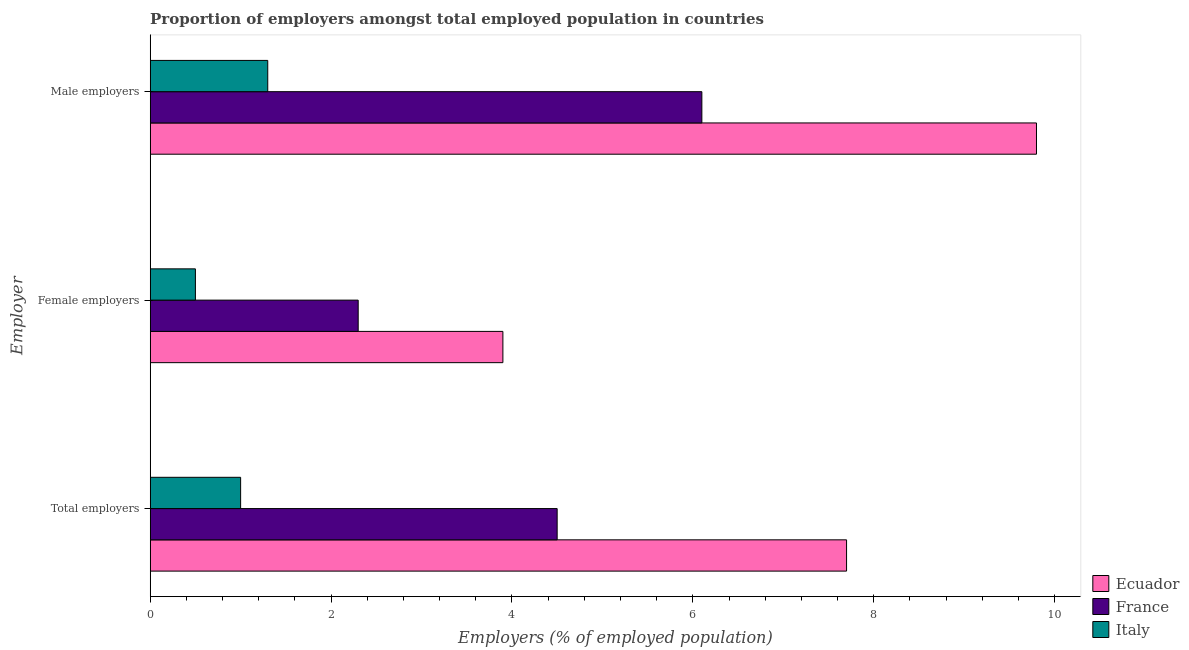Are the number of bars on each tick of the Y-axis equal?
Keep it short and to the point. Yes. How many bars are there on the 3rd tick from the top?
Your answer should be very brief. 3. What is the label of the 1st group of bars from the top?
Offer a very short reply. Male employers. What is the percentage of total employers in Ecuador?
Your response must be concise. 7.7. Across all countries, what is the maximum percentage of total employers?
Your answer should be compact. 7.7. In which country was the percentage of total employers maximum?
Keep it short and to the point. Ecuador. In which country was the percentage of female employers minimum?
Make the answer very short. Italy. What is the total percentage of total employers in the graph?
Your answer should be compact. 13.2. What is the difference between the percentage of total employers in Ecuador and that in France?
Provide a succinct answer. 3.2. What is the difference between the percentage of male employers in Italy and the percentage of total employers in France?
Your answer should be very brief. -3.2. What is the average percentage of total employers per country?
Your answer should be very brief. 4.4. What is the difference between the percentage of male employers and percentage of female employers in Ecuador?
Provide a short and direct response. 5.9. In how many countries, is the percentage of male employers greater than 3.2 %?
Offer a terse response. 2. What is the ratio of the percentage of male employers in Ecuador to that in Italy?
Ensure brevity in your answer.  7.54. Is the percentage of female employers in France less than that in Italy?
Keep it short and to the point. No. Is the difference between the percentage of total employers in France and Italy greater than the difference between the percentage of male employers in France and Italy?
Provide a short and direct response. No. What is the difference between the highest and the second highest percentage of male employers?
Provide a short and direct response. 3.7. What is the difference between the highest and the lowest percentage of total employers?
Provide a short and direct response. 6.7. In how many countries, is the percentage of female employers greater than the average percentage of female employers taken over all countries?
Your answer should be very brief. 2. Is the sum of the percentage of female employers in France and Ecuador greater than the maximum percentage of male employers across all countries?
Ensure brevity in your answer.  No. What does the 2nd bar from the top in Total employers represents?
Your response must be concise. France. Are all the bars in the graph horizontal?
Keep it short and to the point. Yes. Are the values on the major ticks of X-axis written in scientific E-notation?
Provide a short and direct response. No. Does the graph contain any zero values?
Your answer should be compact. No. Does the graph contain grids?
Make the answer very short. No. Where does the legend appear in the graph?
Give a very brief answer. Bottom right. How are the legend labels stacked?
Make the answer very short. Vertical. What is the title of the graph?
Offer a terse response. Proportion of employers amongst total employed population in countries. Does "World" appear as one of the legend labels in the graph?
Give a very brief answer. No. What is the label or title of the X-axis?
Give a very brief answer. Employers (% of employed population). What is the label or title of the Y-axis?
Offer a very short reply. Employer. What is the Employers (% of employed population) in Ecuador in Total employers?
Keep it short and to the point. 7.7. What is the Employers (% of employed population) of France in Total employers?
Offer a terse response. 4.5. What is the Employers (% of employed population) in Ecuador in Female employers?
Ensure brevity in your answer.  3.9. What is the Employers (% of employed population) in France in Female employers?
Provide a short and direct response. 2.3. What is the Employers (% of employed population) of Italy in Female employers?
Provide a succinct answer. 0.5. What is the Employers (% of employed population) of Ecuador in Male employers?
Give a very brief answer. 9.8. What is the Employers (% of employed population) in France in Male employers?
Your response must be concise. 6.1. What is the Employers (% of employed population) of Italy in Male employers?
Provide a short and direct response. 1.3. Across all Employer, what is the maximum Employers (% of employed population) of Ecuador?
Provide a succinct answer. 9.8. Across all Employer, what is the maximum Employers (% of employed population) of France?
Offer a very short reply. 6.1. Across all Employer, what is the maximum Employers (% of employed population) of Italy?
Provide a succinct answer. 1.3. Across all Employer, what is the minimum Employers (% of employed population) in Ecuador?
Your response must be concise. 3.9. Across all Employer, what is the minimum Employers (% of employed population) of France?
Provide a short and direct response. 2.3. What is the total Employers (% of employed population) in Ecuador in the graph?
Provide a short and direct response. 21.4. What is the total Employers (% of employed population) in France in the graph?
Your answer should be very brief. 12.9. What is the difference between the Employers (% of employed population) of Ecuador in Total employers and that in Female employers?
Ensure brevity in your answer.  3.8. What is the difference between the Employers (% of employed population) of France in Total employers and that in Female employers?
Your response must be concise. 2.2. What is the difference between the Employers (% of employed population) in Italy in Total employers and that in Female employers?
Provide a succinct answer. 0.5. What is the difference between the Employers (% of employed population) of Ecuador in Total employers and that in Male employers?
Offer a very short reply. -2.1. What is the difference between the Employers (% of employed population) in France in Female employers and that in Male employers?
Your answer should be very brief. -3.8. What is the difference between the Employers (% of employed population) in Italy in Female employers and that in Male employers?
Your answer should be very brief. -0.8. What is the difference between the Employers (% of employed population) in Ecuador in Total employers and the Employers (% of employed population) in Italy in Female employers?
Ensure brevity in your answer.  7.2. What is the difference between the Employers (% of employed population) in Ecuador in Total employers and the Employers (% of employed population) in France in Male employers?
Give a very brief answer. 1.6. What is the difference between the Employers (% of employed population) of Ecuador in Total employers and the Employers (% of employed population) of Italy in Male employers?
Offer a very short reply. 6.4. What is the difference between the Employers (% of employed population) of France in Total employers and the Employers (% of employed population) of Italy in Male employers?
Make the answer very short. 3.2. What is the average Employers (% of employed population) of Ecuador per Employer?
Ensure brevity in your answer.  7.13. What is the difference between the Employers (% of employed population) in Ecuador and Employers (% of employed population) in France in Total employers?
Keep it short and to the point. 3.2. What is the difference between the Employers (% of employed population) of France and Employers (% of employed population) of Italy in Total employers?
Provide a short and direct response. 3.5. What is the difference between the Employers (% of employed population) in Ecuador and Employers (% of employed population) in Italy in Female employers?
Your response must be concise. 3.4. What is the difference between the Employers (% of employed population) of France and Employers (% of employed population) of Italy in Male employers?
Offer a terse response. 4.8. What is the ratio of the Employers (% of employed population) of Ecuador in Total employers to that in Female employers?
Ensure brevity in your answer.  1.97. What is the ratio of the Employers (% of employed population) in France in Total employers to that in Female employers?
Make the answer very short. 1.96. What is the ratio of the Employers (% of employed population) in Italy in Total employers to that in Female employers?
Ensure brevity in your answer.  2. What is the ratio of the Employers (% of employed population) in Ecuador in Total employers to that in Male employers?
Keep it short and to the point. 0.79. What is the ratio of the Employers (% of employed population) in France in Total employers to that in Male employers?
Give a very brief answer. 0.74. What is the ratio of the Employers (% of employed population) in Italy in Total employers to that in Male employers?
Your response must be concise. 0.77. What is the ratio of the Employers (% of employed population) of Ecuador in Female employers to that in Male employers?
Offer a very short reply. 0.4. What is the ratio of the Employers (% of employed population) of France in Female employers to that in Male employers?
Your answer should be very brief. 0.38. What is the ratio of the Employers (% of employed population) of Italy in Female employers to that in Male employers?
Offer a terse response. 0.38. What is the difference between the highest and the second highest Employers (% of employed population) in France?
Your response must be concise. 1.6. What is the difference between the highest and the lowest Employers (% of employed population) in Ecuador?
Offer a very short reply. 5.9. 